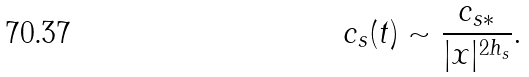<formula> <loc_0><loc_0><loc_500><loc_500>c _ { s } ( t ) \sim \frac { c _ { s * } } { | x | ^ { 2 h _ { s } } } .</formula> 